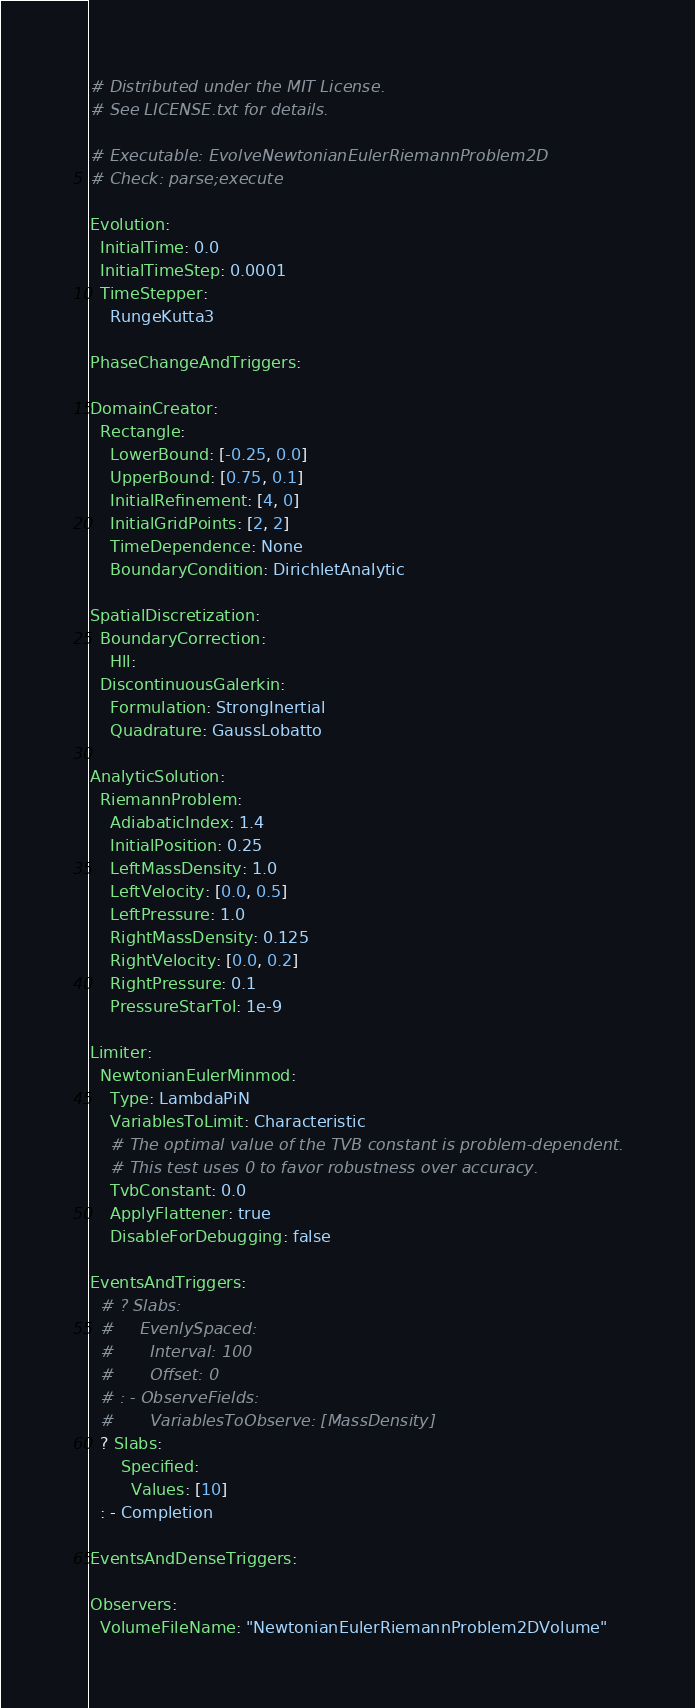<code> <loc_0><loc_0><loc_500><loc_500><_YAML_># Distributed under the MIT License.
# See LICENSE.txt for details.

# Executable: EvolveNewtonianEulerRiemannProblem2D
# Check: parse;execute

Evolution:
  InitialTime: 0.0
  InitialTimeStep: 0.0001
  TimeStepper:
    RungeKutta3

PhaseChangeAndTriggers:

DomainCreator:
  Rectangle:
    LowerBound: [-0.25, 0.0]
    UpperBound: [0.75, 0.1]
    InitialRefinement: [4, 0]
    InitialGridPoints: [2, 2]
    TimeDependence: None
    BoundaryCondition: DirichletAnalytic

SpatialDiscretization:
  BoundaryCorrection:
    Hll:
  DiscontinuousGalerkin:
    Formulation: StrongInertial
    Quadrature: GaussLobatto

AnalyticSolution:
  RiemannProblem:
    AdiabaticIndex: 1.4
    InitialPosition: 0.25
    LeftMassDensity: 1.0
    LeftVelocity: [0.0, 0.5]
    LeftPressure: 1.0
    RightMassDensity: 0.125
    RightVelocity: [0.0, 0.2]
    RightPressure: 0.1
    PressureStarTol: 1e-9

Limiter:
  NewtonianEulerMinmod:
    Type: LambdaPiN
    VariablesToLimit: Characteristic
    # The optimal value of the TVB constant is problem-dependent.
    # This test uses 0 to favor robustness over accuracy.
    TvbConstant: 0.0
    ApplyFlattener: true
    DisableForDebugging: false

EventsAndTriggers:
  # ? Slabs:
  #     EvenlySpaced:
  #       Interval: 100
  #       Offset: 0
  # : - ObserveFields:
  #       VariablesToObserve: [MassDensity]
  ? Slabs:
      Specified:
        Values: [10]
  : - Completion

EventsAndDenseTriggers:

Observers:
  VolumeFileName: "NewtonianEulerRiemannProblem2DVolume"</code> 